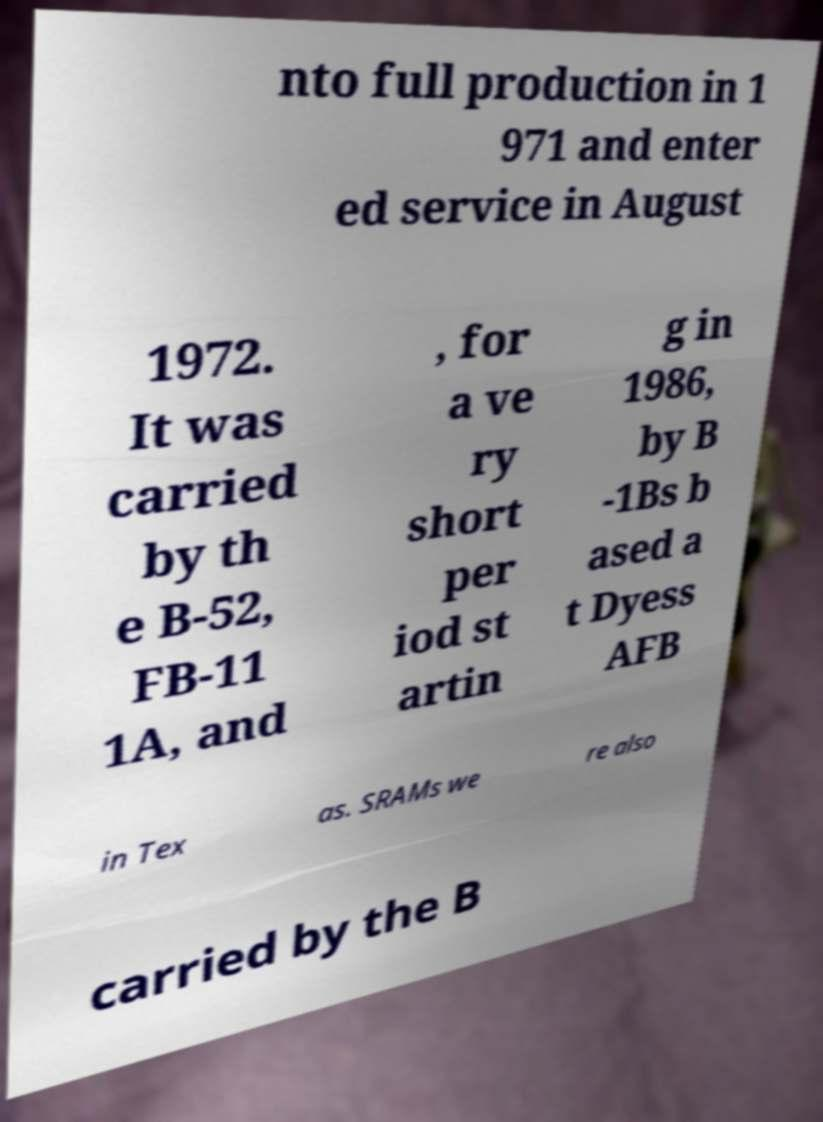Please identify and transcribe the text found in this image. nto full production in 1 971 and enter ed service in August 1972. It was carried by th e B-52, FB-11 1A, and , for a ve ry short per iod st artin g in 1986, by B -1Bs b ased a t Dyess AFB in Tex as. SRAMs we re also carried by the B 